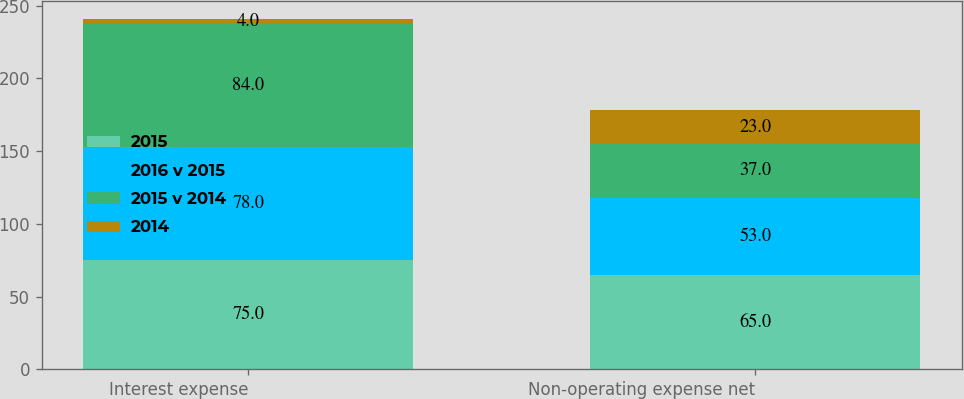<chart> <loc_0><loc_0><loc_500><loc_500><stacked_bar_chart><ecel><fcel>Interest expense<fcel>Non-operating expense net<nl><fcel>2015<fcel>75<fcel>65<nl><fcel>2016 v 2015<fcel>78<fcel>53<nl><fcel>2015 v 2014<fcel>84<fcel>37<nl><fcel>2014<fcel>4<fcel>23<nl></chart> 